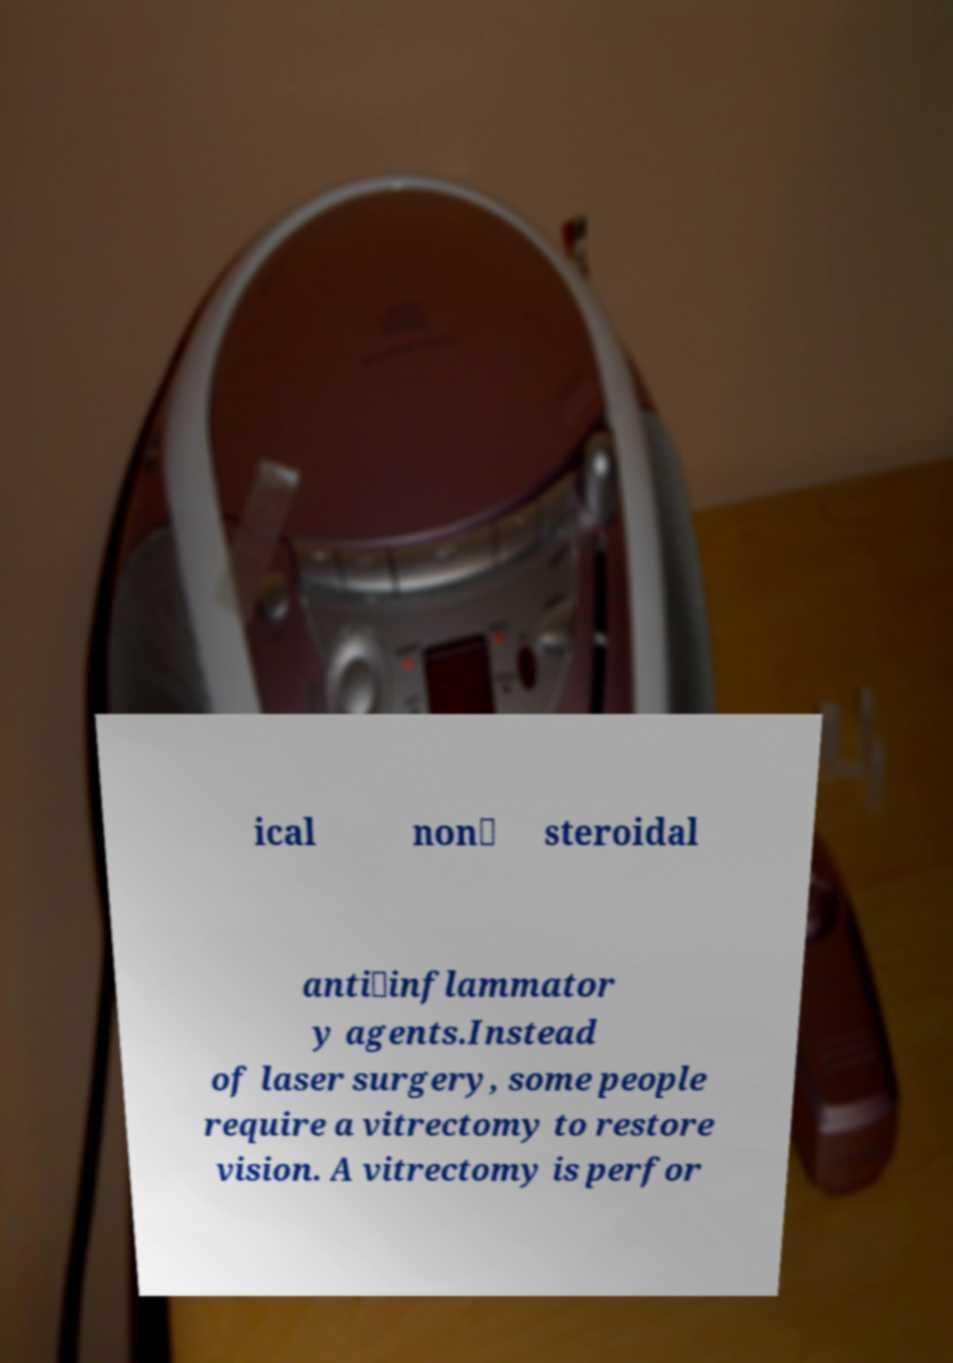What messages or text are displayed in this image? I need them in a readable, typed format. ical non‐ steroidal anti‐inflammator y agents.Instead of laser surgery, some people require a vitrectomy to restore vision. A vitrectomy is perfor 